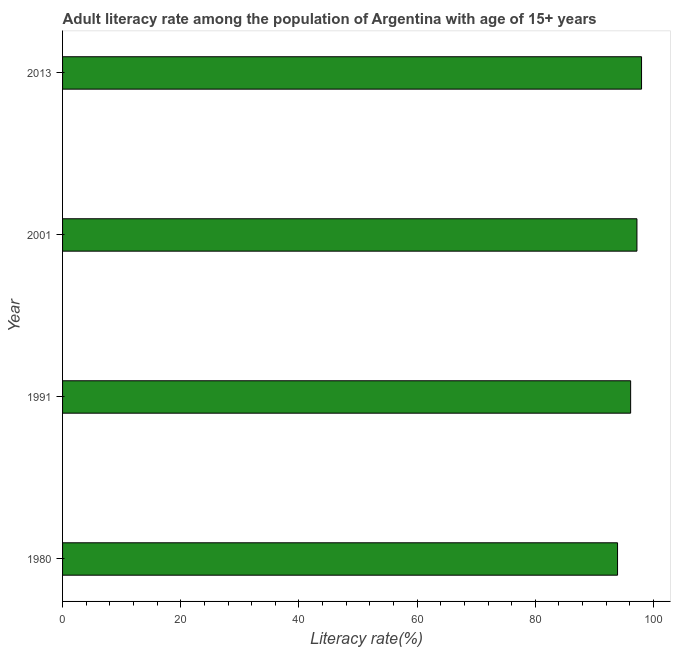Does the graph contain grids?
Make the answer very short. No. What is the title of the graph?
Keep it short and to the point. Adult literacy rate among the population of Argentina with age of 15+ years. What is the label or title of the X-axis?
Provide a short and direct response. Literacy rate(%). What is the adult literacy rate in 1980?
Your answer should be compact. 93.91. Across all years, what is the maximum adult literacy rate?
Your response must be concise. 97.97. Across all years, what is the minimum adult literacy rate?
Provide a short and direct response. 93.91. In which year was the adult literacy rate maximum?
Your answer should be very brief. 2013. What is the sum of the adult literacy rate?
Offer a very short reply. 385.21. What is the difference between the adult literacy rate in 1980 and 2001?
Give a very brief answer. -3.28. What is the average adult literacy rate per year?
Your answer should be very brief. 96.3. What is the median adult literacy rate?
Provide a succinct answer. 96.66. Do a majority of the years between 1991 and 1980 (inclusive) have adult literacy rate greater than 72 %?
Ensure brevity in your answer.  No. Is the adult literacy rate in 2001 less than that in 2013?
Keep it short and to the point. Yes. Is the difference between the adult literacy rate in 1991 and 2001 greater than the difference between any two years?
Offer a terse response. No. What is the difference between the highest and the second highest adult literacy rate?
Keep it short and to the point. 0.78. What is the difference between the highest and the lowest adult literacy rate?
Offer a very short reply. 4.06. How many bars are there?
Keep it short and to the point. 4. What is the difference between two consecutive major ticks on the X-axis?
Make the answer very short. 20. What is the Literacy rate(%) in 1980?
Keep it short and to the point. 93.91. What is the Literacy rate(%) in 1991?
Ensure brevity in your answer.  96.13. What is the Literacy rate(%) of 2001?
Your answer should be compact. 97.19. What is the Literacy rate(%) in 2013?
Your answer should be very brief. 97.97. What is the difference between the Literacy rate(%) in 1980 and 1991?
Offer a very short reply. -2.22. What is the difference between the Literacy rate(%) in 1980 and 2001?
Your answer should be compact. -3.28. What is the difference between the Literacy rate(%) in 1980 and 2013?
Your answer should be compact. -4.06. What is the difference between the Literacy rate(%) in 1991 and 2001?
Give a very brief answer. -1.07. What is the difference between the Literacy rate(%) in 1991 and 2013?
Provide a succinct answer. -1.85. What is the difference between the Literacy rate(%) in 2001 and 2013?
Offer a very short reply. -0.78. What is the ratio of the Literacy rate(%) in 1991 to that in 2001?
Keep it short and to the point. 0.99. 